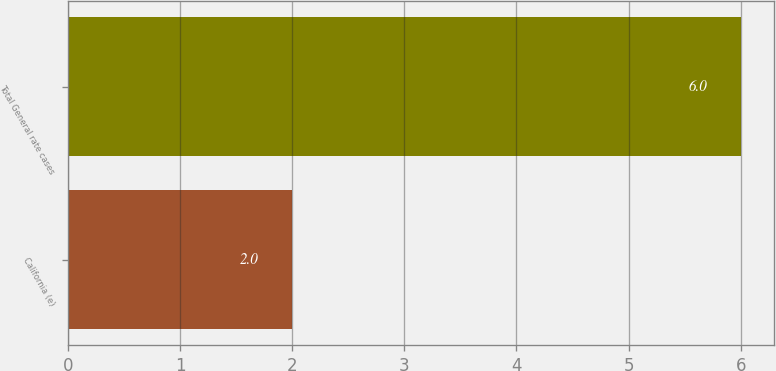Convert chart. <chart><loc_0><loc_0><loc_500><loc_500><bar_chart><fcel>California (e)<fcel>Total General rate cases<nl><fcel>2<fcel>6<nl></chart> 